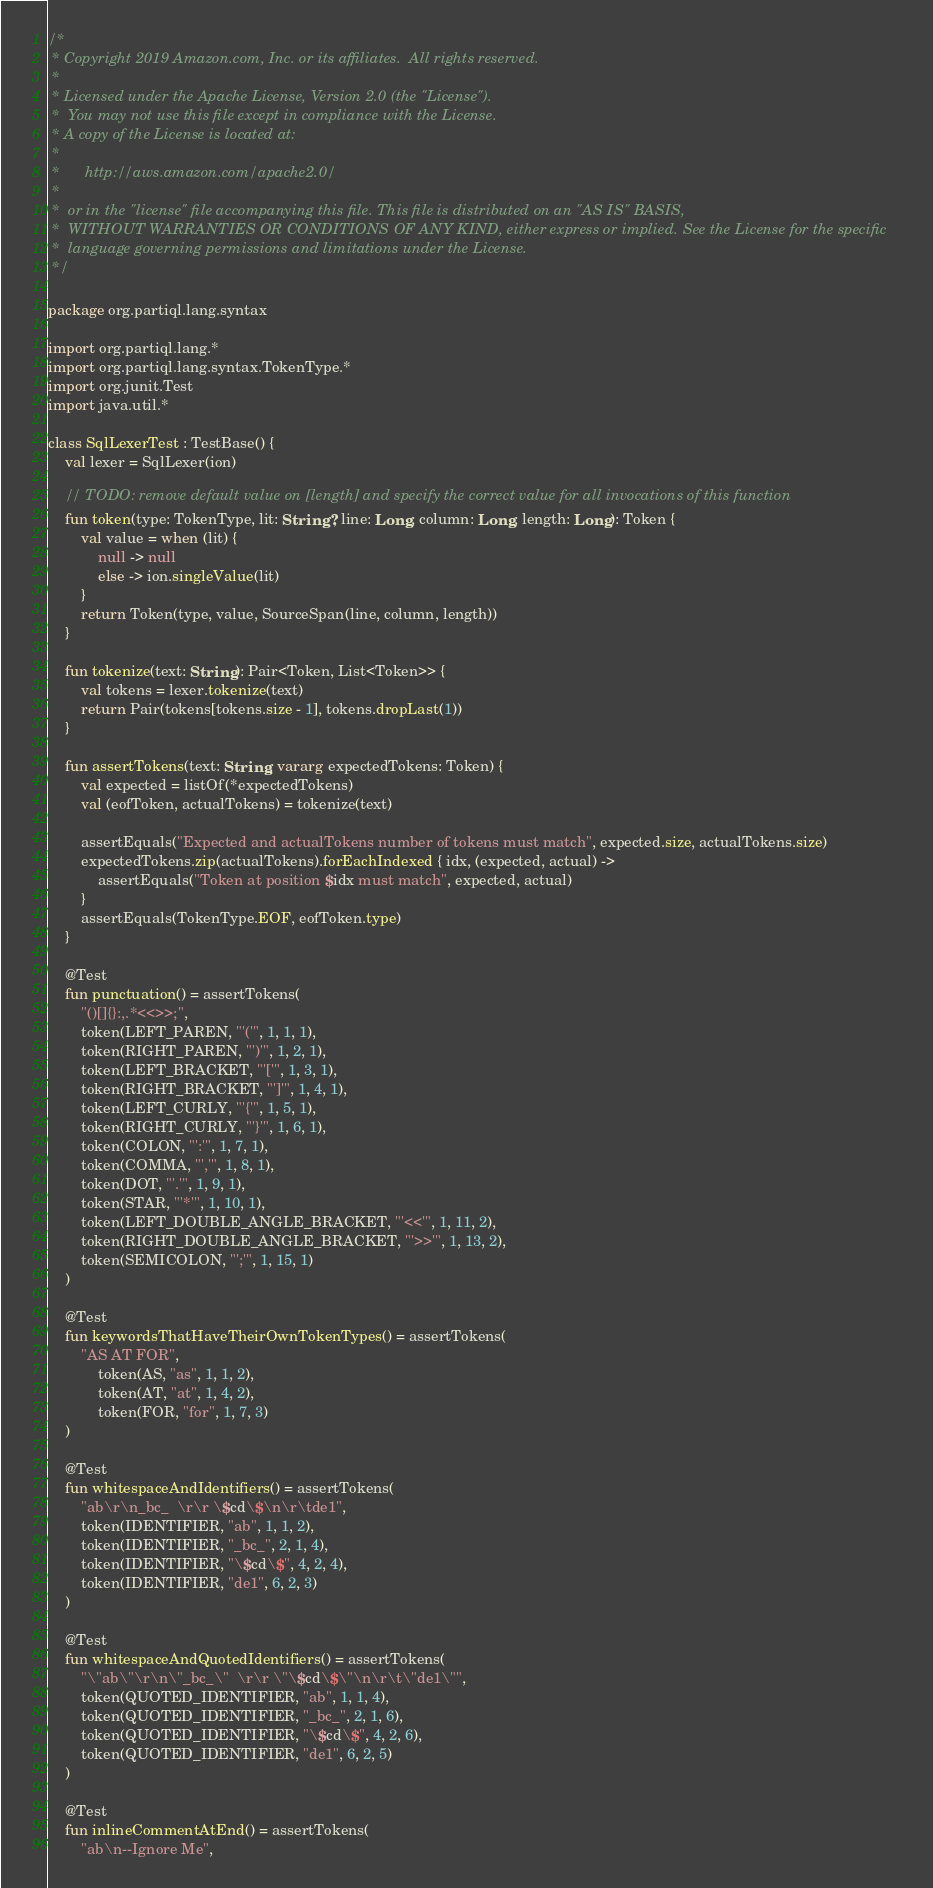Convert code to text. <code><loc_0><loc_0><loc_500><loc_500><_Kotlin_>/*
 * Copyright 2019 Amazon.com, Inc. or its affiliates.  All rights reserved.
 *
 * Licensed under the Apache License, Version 2.0 (the "License").
 *  You may not use this file except in compliance with the License.
 * A copy of the License is located at:
 *
 *      http://aws.amazon.com/apache2.0/
 *
 *  or in the "license" file accompanying this file. This file is distributed on an "AS IS" BASIS,
 *  WITHOUT WARRANTIES OR CONDITIONS OF ANY KIND, either express or implied. See the License for the specific
 *  language governing permissions and limitations under the License.
 */

package org.partiql.lang.syntax

import org.partiql.lang.*
import org.partiql.lang.syntax.TokenType.*
import org.junit.Test
import java.util.*

class SqlLexerTest : TestBase() {
    val lexer = SqlLexer(ion)

    // TODO: remove default value on [length] and specify the correct value for all invocations of this function
    fun token(type: TokenType, lit: String?, line: Long, column: Long, length: Long): Token {
        val value = when (lit) {
            null -> null
            else -> ion.singleValue(lit)
        }
        return Token(type, value, SourceSpan(line, column, length))
    }

    fun tokenize(text: String): Pair<Token, List<Token>> {
        val tokens = lexer.tokenize(text)
        return Pair(tokens[tokens.size - 1], tokens.dropLast(1))
    }

    fun assertTokens(text: String, vararg expectedTokens: Token) {
        val expected = listOf(*expectedTokens)
        val (eofToken, actualTokens) = tokenize(text)

        assertEquals("Expected and actualTokens number of tokens must match", expected.size, actualTokens.size)
        expectedTokens.zip(actualTokens).forEachIndexed { idx, (expected, actual) ->
            assertEquals("Token at position $idx must match", expected, actual)
        }
        assertEquals(TokenType.EOF, eofToken.type)
    }

    @Test
    fun punctuation() = assertTokens(
        "()[]{}:,.*<<>>;",
        token(LEFT_PAREN, "'('", 1, 1, 1),
        token(RIGHT_PAREN, "')'", 1, 2, 1),
        token(LEFT_BRACKET, "'['", 1, 3, 1),
        token(RIGHT_BRACKET, "']'", 1, 4, 1),
        token(LEFT_CURLY, "'{'", 1, 5, 1),
        token(RIGHT_CURLY, "'}'", 1, 6, 1),
        token(COLON, "':'", 1, 7, 1),
        token(COMMA, "','", 1, 8, 1),
        token(DOT, "'.'", 1, 9, 1),
        token(STAR, "'*'", 1, 10, 1),
        token(LEFT_DOUBLE_ANGLE_BRACKET, "'<<'", 1, 11, 2),
        token(RIGHT_DOUBLE_ANGLE_BRACKET, "'>>'", 1, 13, 2),
        token(SEMICOLON, "';'", 1, 15, 1)
    )

    @Test
    fun keywordsThatHaveTheirOwnTokenTypes() = assertTokens(
        "AS AT FOR",
            token(AS, "as", 1, 1, 2),
            token(AT, "at", 1, 4, 2),
            token(FOR, "for", 1, 7, 3)
    )

    @Test
    fun whitespaceAndIdentifiers() = assertTokens(
        "ab\r\n_bc_  \r\r \$cd\$\n\r\tde1",
        token(IDENTIFIER, "ab", 1, 1, 2),
        token(IDENTIFIER, "_bc_", 2, 1, 4),
        token(IDENTIFIER, "\$cd\$", 4, 2, 4),
        token(IDENTIFIER, "de1", 6, 2, 3)
    )

    @Test
    fun whitespaceAndQuotedIdentifiers() = assertTokens(
        "\"ab\"\r\n\"_bc_\"  \r\r \"\$cd\$\"\n\r\t\"de1\"",
        token(QUOTED_IDENTIFIER, "ab", 1, 1, 4),
        token(QUOTED_IDENTIFIER, "_bc_", 2, 1, 6),
        token(QUOTED_IDENTIFIER, "\$cd\$", 4, 2, 6),
        token(QUOTED_IDENTIFIER, "de1", 6, 2, 5)
    )

    @Test
    fun inlineCommentAtEnd() = assertTokens(
        "ab\n--Ignore Me",</code> 